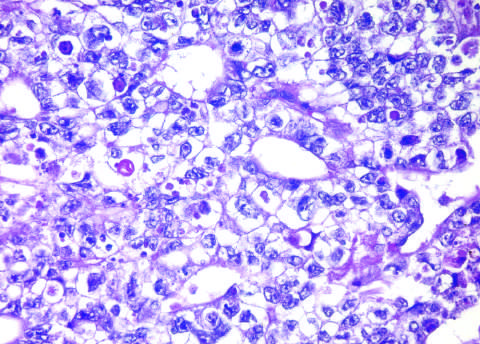s the tumor hemorrhagic?
Answer the question using a single word or phrase. Yes 